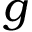<formula> <loc_0><loc_0><loc_500><loc_500>g</formula> 